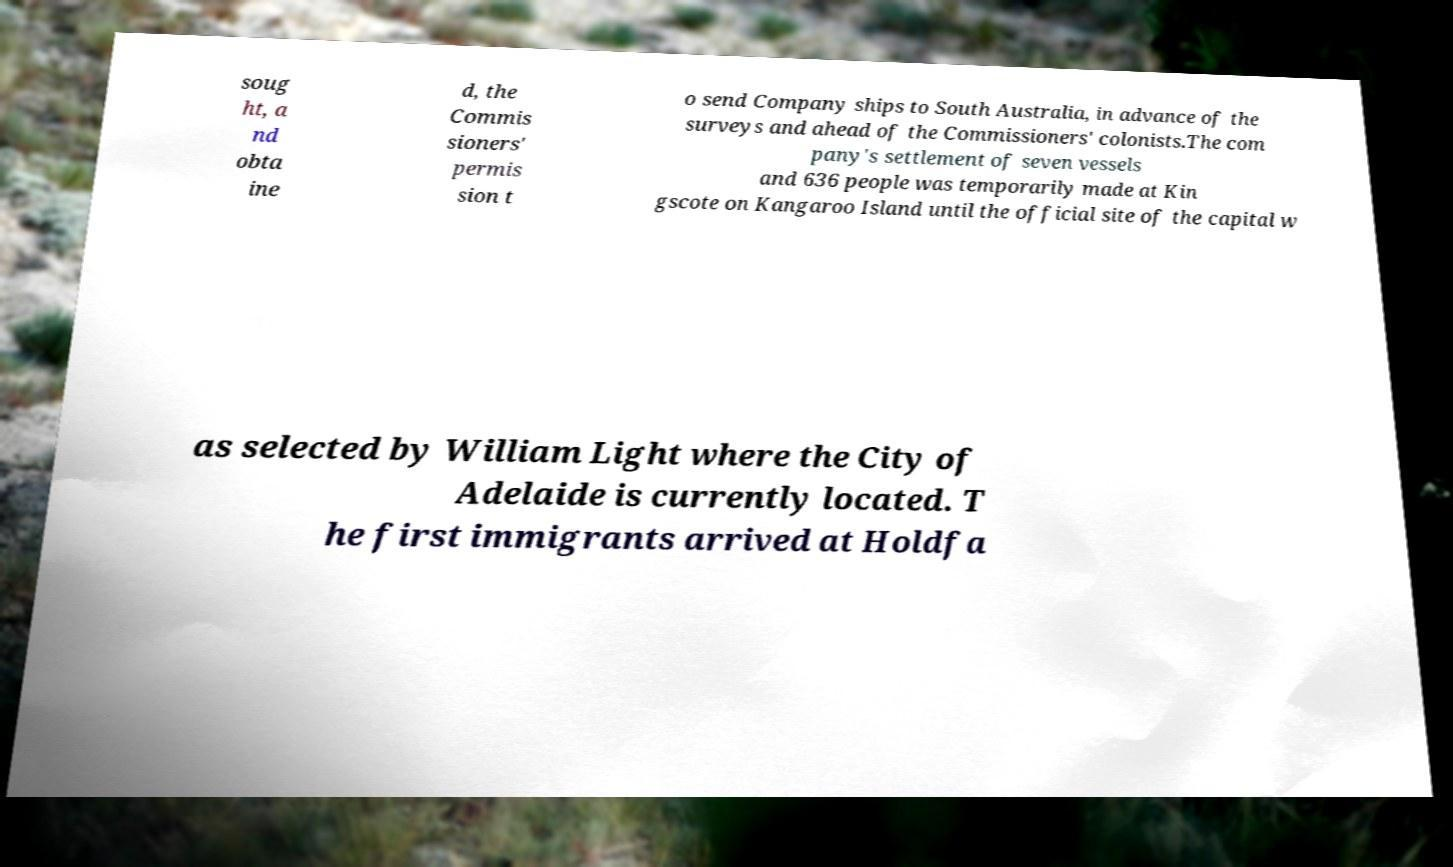Can you read and provide the text displayed in the image?This photo seems to have some interesting text. Can you extract and type it out for me? soug ht, a nd obta ine d, the Commis sioners' permis sion t o send Company ships to South Australia, in advance of the surveys and ahead of the Commissioners' colonists.The com pany's settlement of seven vessels and 636 people was temporarily made at Kin gscote on Kangaroo Island until the official site of the capital w as selected by William Light where the City of Adelaide is currently located. T he first immigrants arrived at Holdfa 